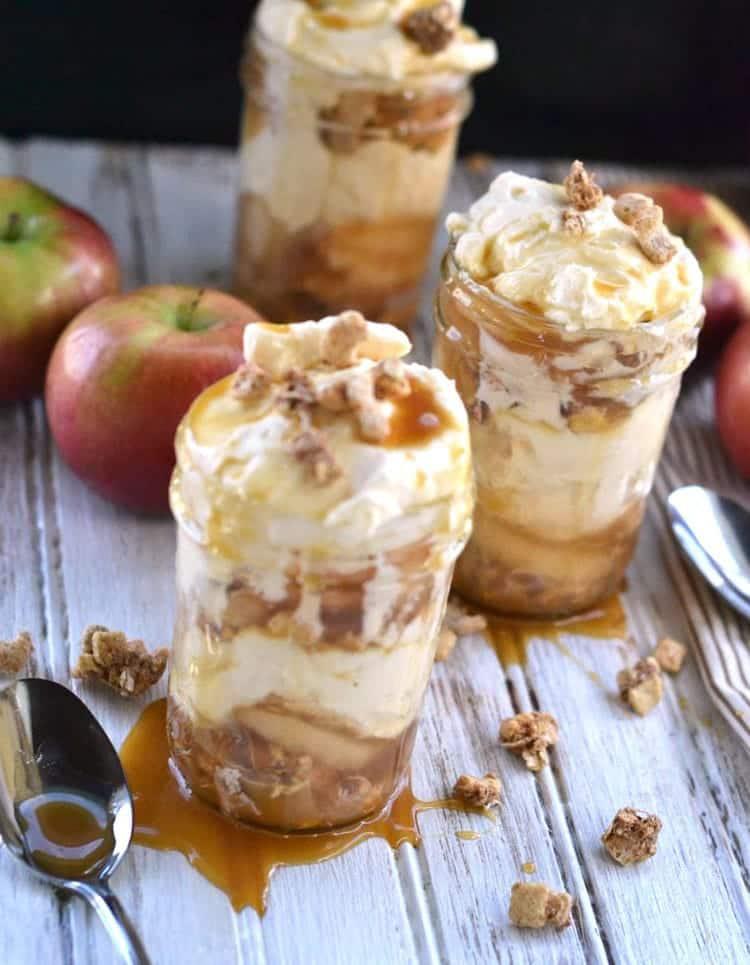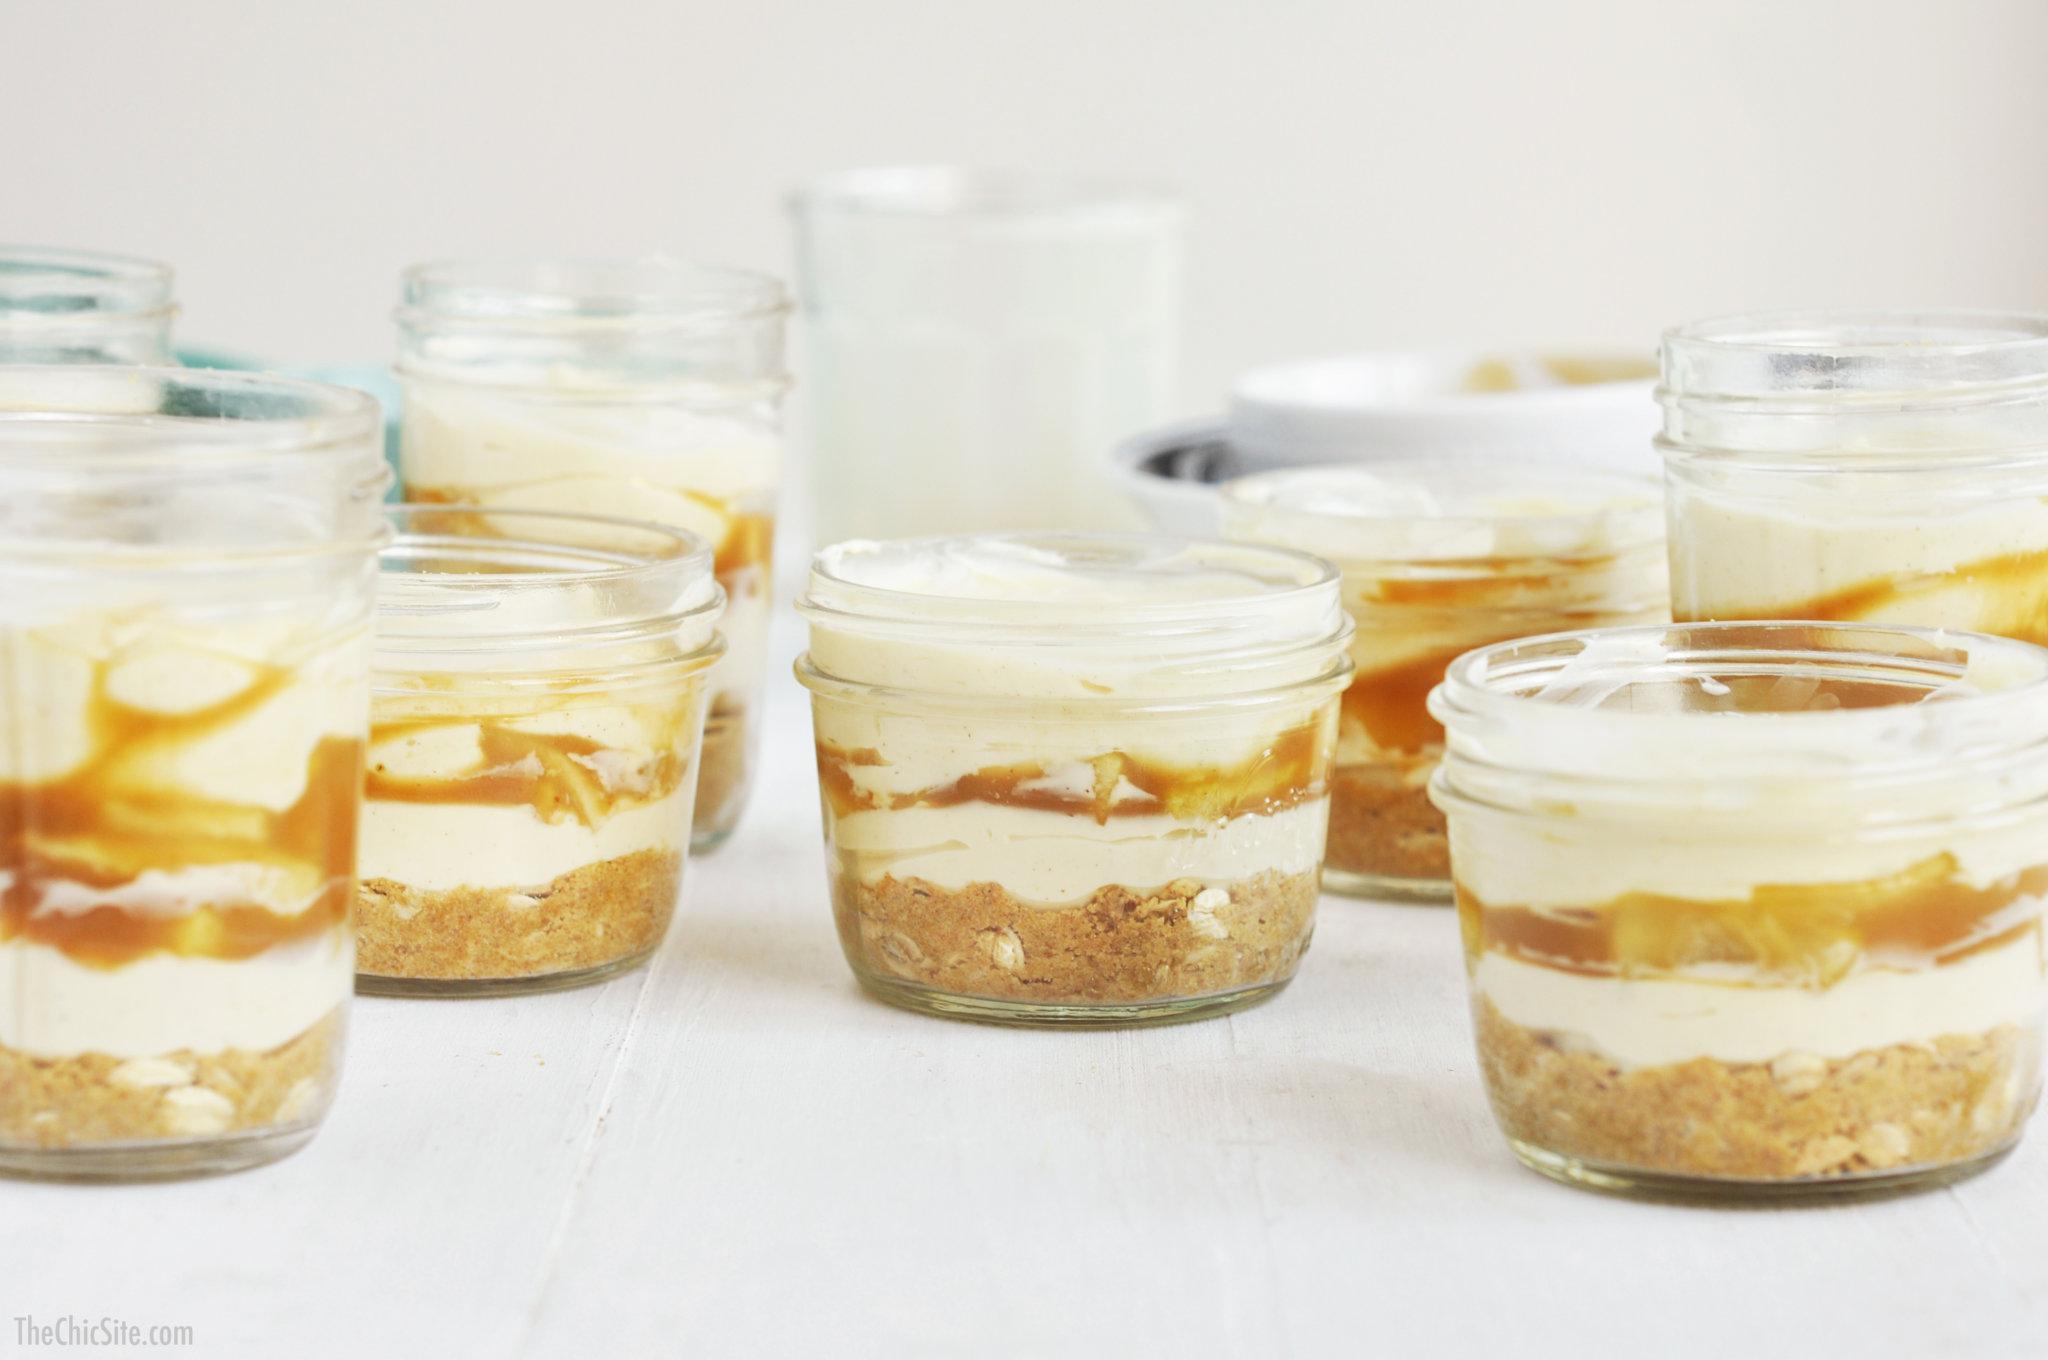The first image is the image on the left, the second image is the image on the right. Considering the images on both sides, is "An image shows a dessert with two white layers, no whipped cream on top, and caramel drizzled down the exterior of the serving jar." valid? Answer yes or no. No. 